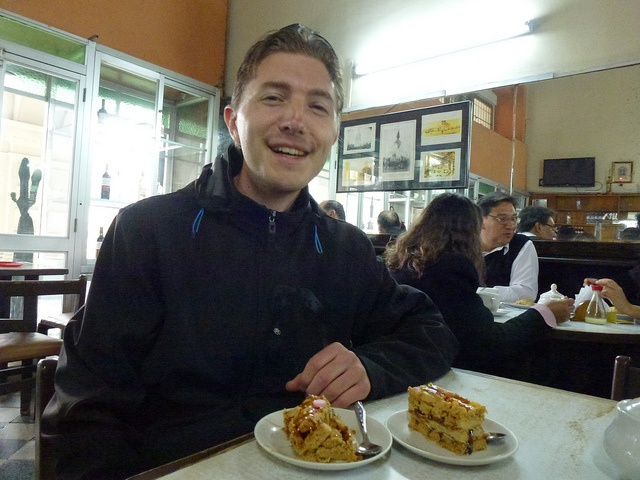Describe the objects in this image and their specific colors. I can see people in olive, black, gray, and maroon tones, dining table in olive, darkgray, and gray tones, people in olive, black, gray, and maroon tones, chair in olive, black, gray, white, and maroon tones, and people in olive, black, darkgray, gray, and maroon tones in this image. 